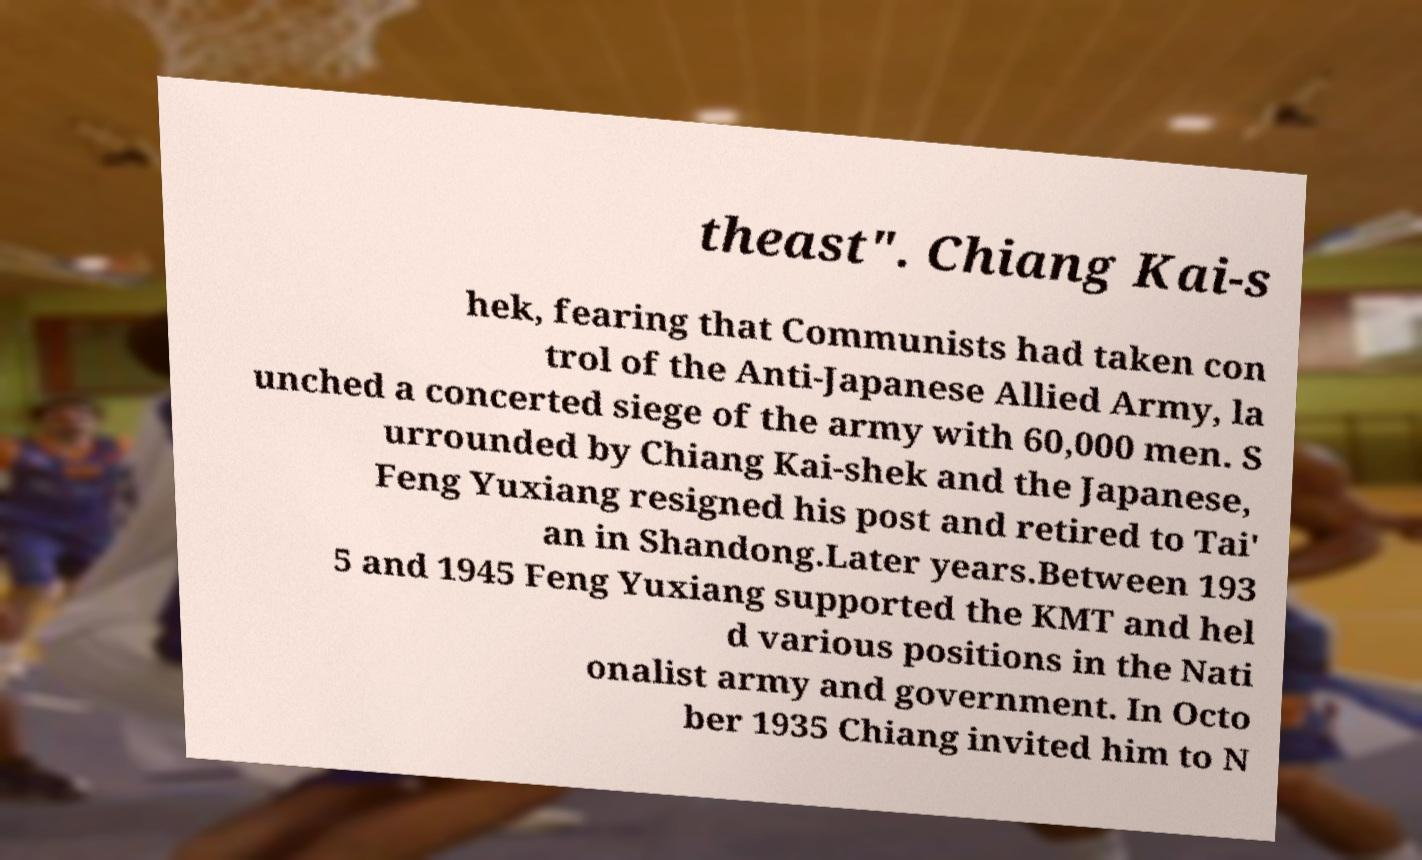Can you read and provide the text displayed in the image?This photo seems to have some interesting text. Can you extract and type it out for me? theast". Chiang Kai-s hek, fearing that Communists had taken con trol of the Anti-Japanese Allied Army, la unched a concerted siege of the army with 60,000 men. S urrounded by Chiang Kai-shek and the Japanese, Feng Yuxiang resigned his post and retired to Tai' an in Shandong.Later years.Between 193 5 and 1945 Feng Yuxiang supported the KMT and hel d various positions in the Nati onalist army and government. In Octo ber 1935 Chiang invited him to N 